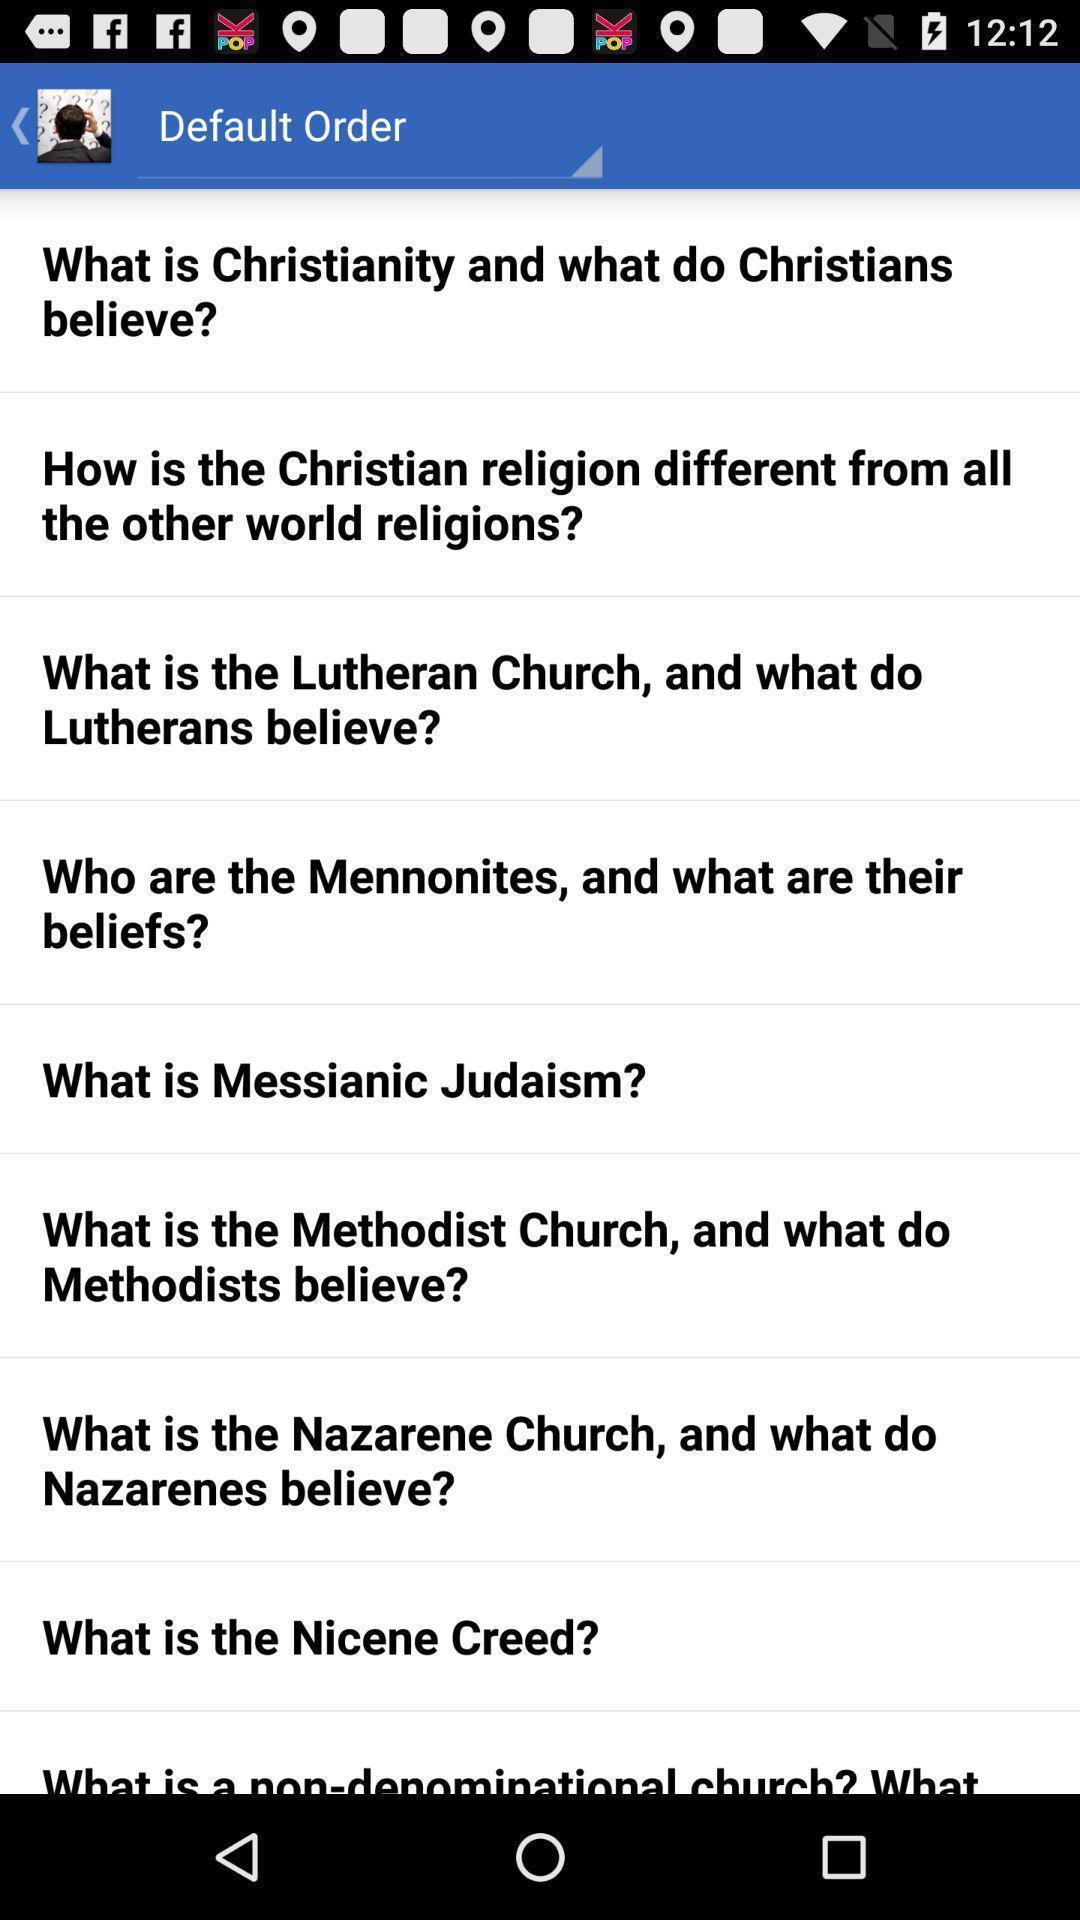Provide a textual representation of this image. Screen shows list of questions in holy book app. 